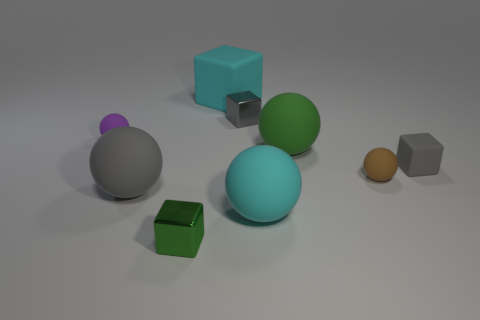Is the cyan thing that is left of the cyan matte sphere made of the same material as the purple thing?
Provide a short and direct response. Yes. Is there a red block that has the same size as the gray sphere?
Your response must be concise. No. There is a gray shiny thing; is it the same shape as the big thing that is to the left of the tiny green shiny object?
Offer a very short reply. No. Are there any gray metal objects behind the large matte thing behind the tiny shiny cube behind the brown matte thing?
Provide a succinct answer. No. How big is the purple object?
Your answer should be very brief. Small. What number of other things are there of the same color as the large rubber block?
Provide a short and direct response. 1. There is a small metal object that is in front of the tiny purple matte object; is it the same shape as the large gray rubber thing?
Provide a succinct answer. No. There is a small rubber object that is the same shape as the green metallic object; what color is it?
Keep it short and to the point. Gray. Is there any other thing that is made of the same material as the small green object?
Your answer should be compact. Yes. What is the size of the cyan thing that is the same shape as the small green thing?
Provide a short and direct response. Large. 